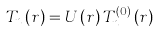<formula> <loc_0><loc_0><loc_500><loc_500>T _ { n } \left ( { r } \right ) = U \left ( { r } \right ) T _ { n } ^ { \left ( 0 \right ) } \left ( { r } \right )</formula> 